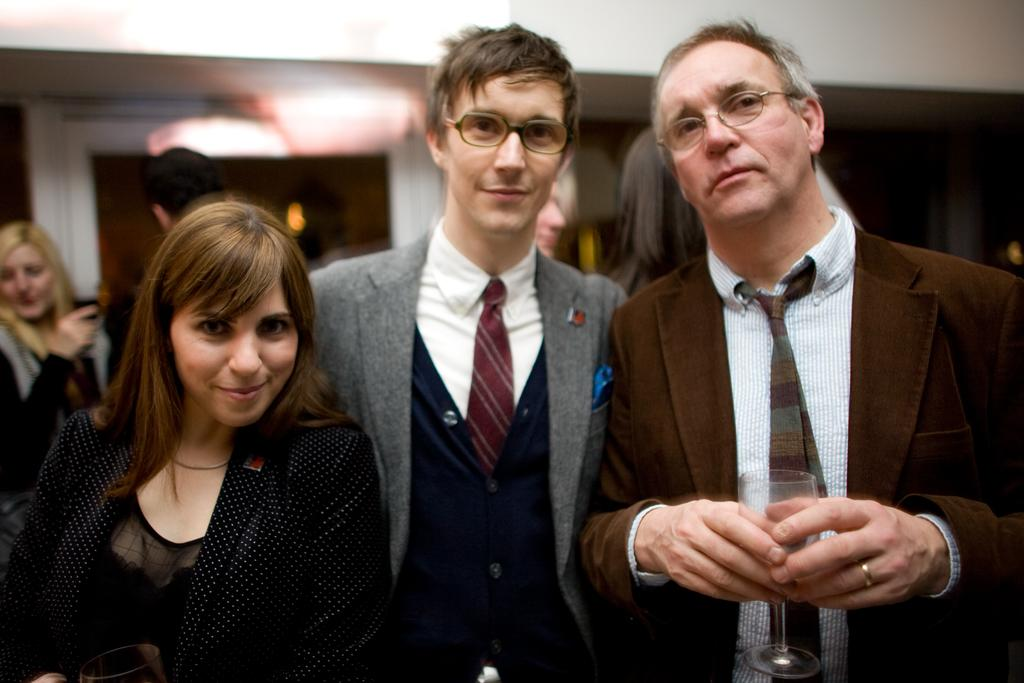How many people are standing in the image? There are three persons standing in the image. What part of the persons' bodies is visible in the image? The back side of the three persons is visible. Can you describe the background of the image? There are other persons visible in the background, and there is a wall in the background of the image. How is the image lit? The image has a light focus. What type of oatmeal is being served on the cushion in the image? There is no oatmeal or cushion present in the image. 